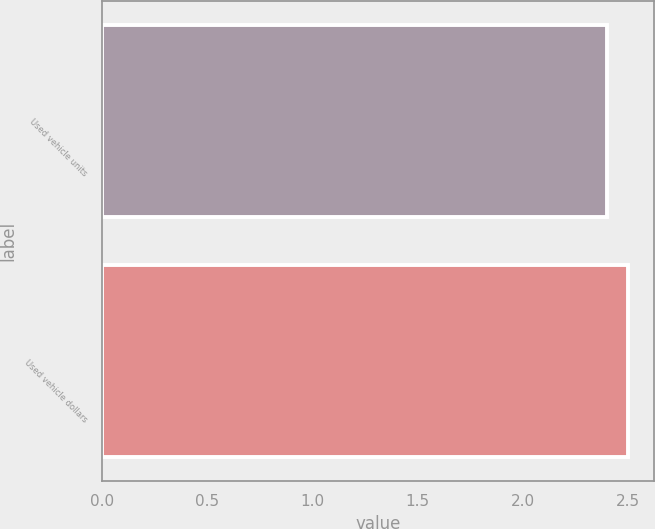<chart> <loc_0><loc_0><loc_500><loc_500><bar_chart><fcel>Used vehicle units<fcel>Used vehicle dollars<nl><fcel>2.4<fcel>2.5<nl></chart> 